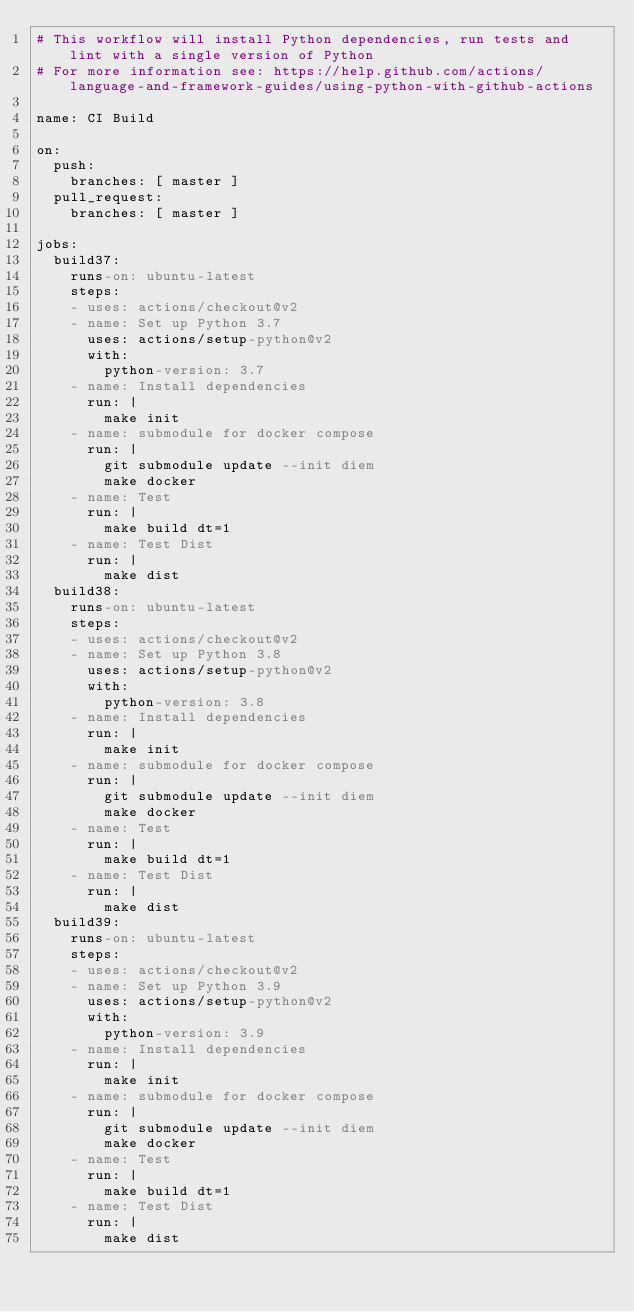<code> <loc_0><loc_0><loc_500><loc_500><_YAML_># This workflow will install Python dependencies, run tests and lint with a single version of Python
# For more information see: https://help.github.com/actions/language-and-framework-guides/using-python-with-github-actions

name: CI Build

on:
  push:
    branches: [ master ]
  pull_request:
    branches: [ master ]

jobs:
  build37:
    runs-on: ubuntu-latest
    steps:
    - uses: actions/checkout@v2
    - name: Set up Python 3.7
      uses: actions/setup-python@v2
      with:
        python-version: 3.7
    - name: Install dependencies
      run: |
        make init
    - name: submodule for docker compose
      run: |
        git submodule update --init diem
        make docker
    - name: Test
      run: |
        make build dt=1
    - name: Test Dist
      run: |
        make dist
  build38:
    runs-on: ubuntu-latest
    steps:
    - uses: actions/checkout@v2
    - name: Set up Python 3.8
      uses: actions/setup-python@v2
      with:
        python-version: 3.8
    - name: Install dependencies
      run: |
        make init
    - name: submodule for docker compose
      run: |
        git submodule update --init diem
        make docker
    - name: Test
      run: |
        make build dt=1
    - name: Test Dist
      run: |
        make dist
  build39:
    runs-on: ubuntu-latest
    steps:
    - uses: actions/checkout@v2
    - name: Set up Python 3.9
      uses: actions/setup-python@v2
      with:
        python-version: 3.9
    - name: Install dependencies
      run: |
        make init
    - name: submodule for docker compose
      run: |
        git submodule update --init diem
        make docker
    - name: Test
      run: |
        make build dt=1
    - name: Test Dist
      run: |
        make dist
</code> 